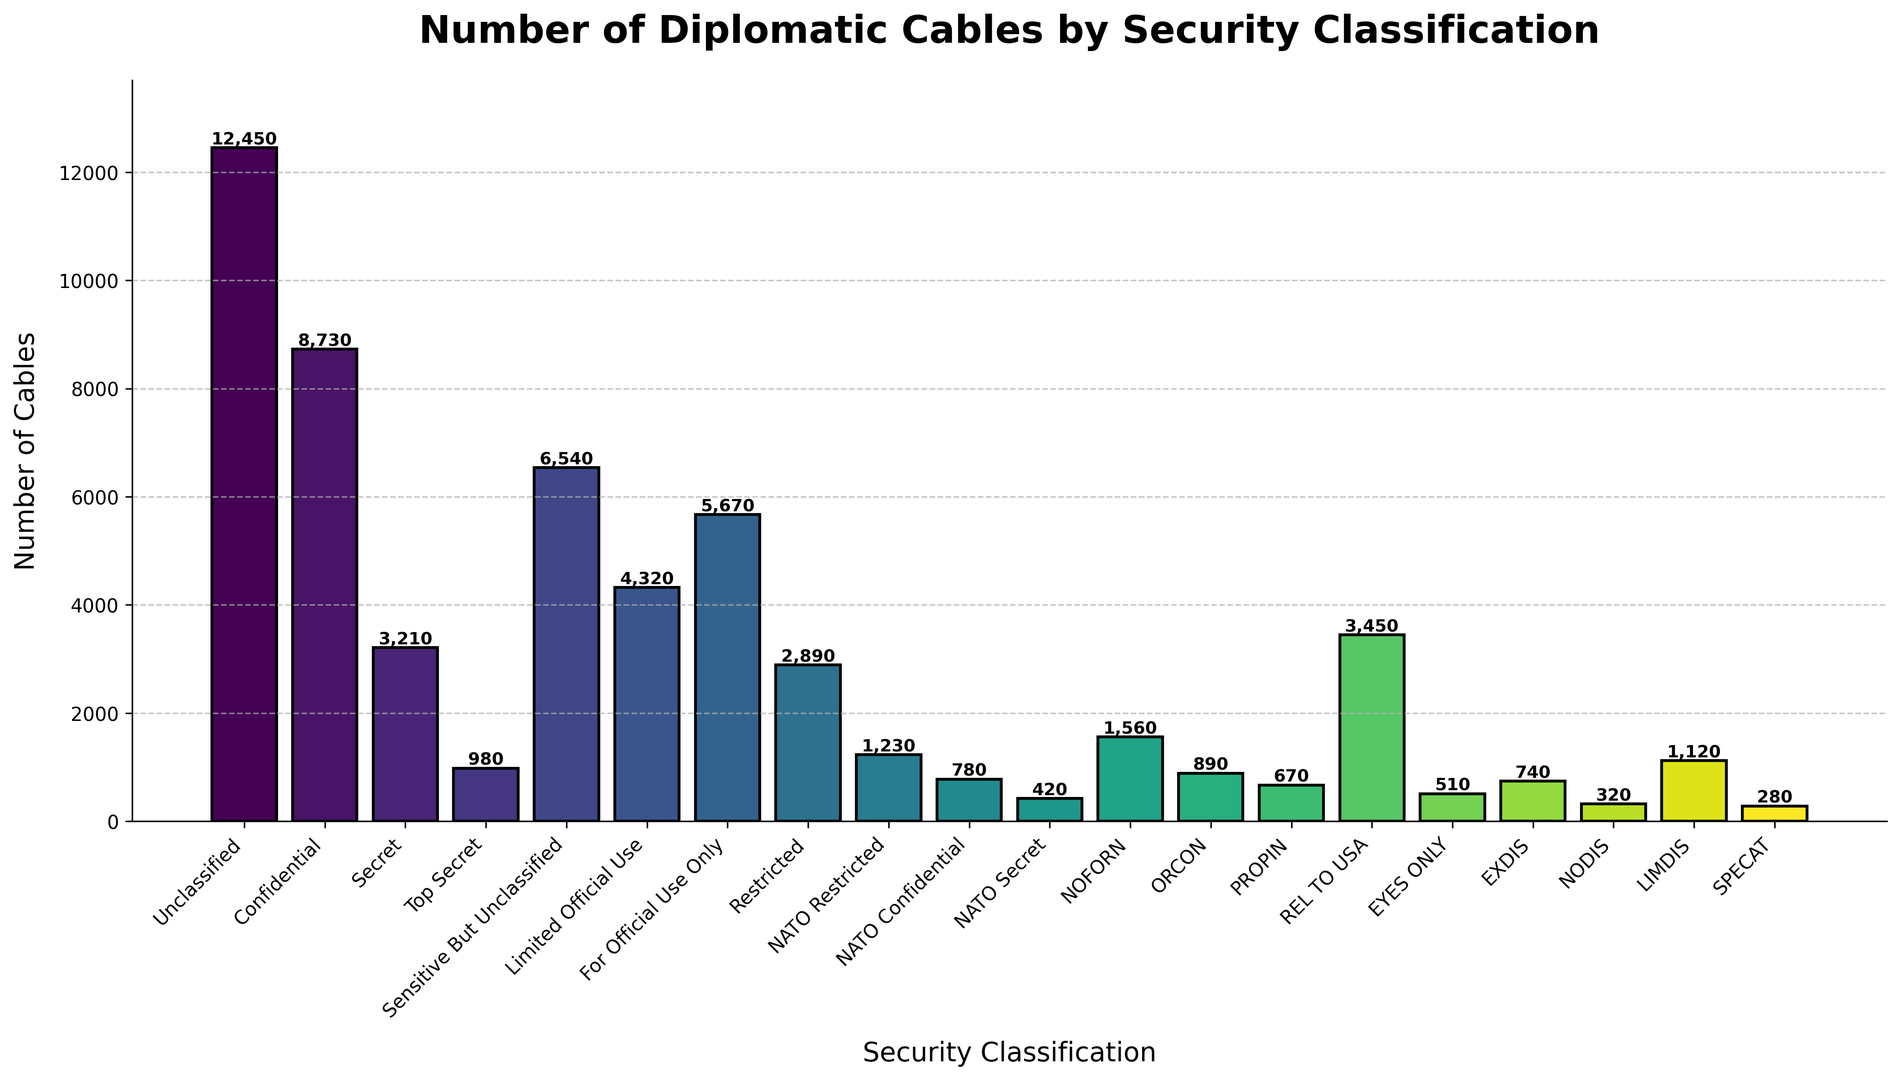Which security classification has the highest number of cables sent? According to the bar heights in the histogram, the classification with the tallest bar represents the highest count. The "Unclassified" bar is the highest.
Answer: Unclassified Which classification has a higher number of cables: "Confidential" or "Secret"? Comparing the heights of the bars labeled "Confidential" and "Secret", the "Confidential" bar is taller.
Answer: Confidential What is the combined number of diplomatic cables sent for classifications "Top Secret" and "EXDIS"? Adding the numbers for "Top Secret" (980) and "EXDIS" (740), we get 980 + 740 = 1,720.
Answer: 1,720 Is the number of "Limited Official Use" cables greater than the number of "Sensitive But Unclassified" cables? Comparing the bar heights for "Limited Official Use" (4,320) and "Sensitive But Unclassified" (6,540), "Sensitive But Unclassified" is greater.
Answer: No What is the total number of cables sent for all NATO classifications combined? Summing the number of cables for "NATO Restricted" (1,230), "NATO Confidential" (780), and "NATO Secret" (420), we get 1,230 + 780 + 420 = 2,430.
Answer: 2,430 Which classification has the lowest number of cables sent? The shortest bar in the histogram represents the lowest count, which is "SPECAT" with 280 cables.
Answer: SPECAT How does the number of "NOFORN" cables compare to "For Official Use Only"? Comparing the heights, "For Official Use Only" (5,670) is taller than "NOFORN" (1,560).
Answer: NOFORN has fewer cables Are there more "Restricted" cables than "LIMDIS" cables? Comparing "Restricted" (2,890) and "LIMDIS" (1,120), "Restricted" has more cables.
Answer: Yes What is the difference in the number of cables between "EYES ONLY" and "REL TO USA"? Subtracting the number of "EYES ONLY" cables (510) from "REL TO USA" cables (3,450), 3,450 - 510 = 2,940.
Answer: 2,940 How many more cables are classified "Unclassified" than "Confidential"? Subtracting the number of "Confidential" cables (8,730) from "Unclassified" cables (12,450), 12,450 - 8,730 = 3,720.
Answer: 3,720 